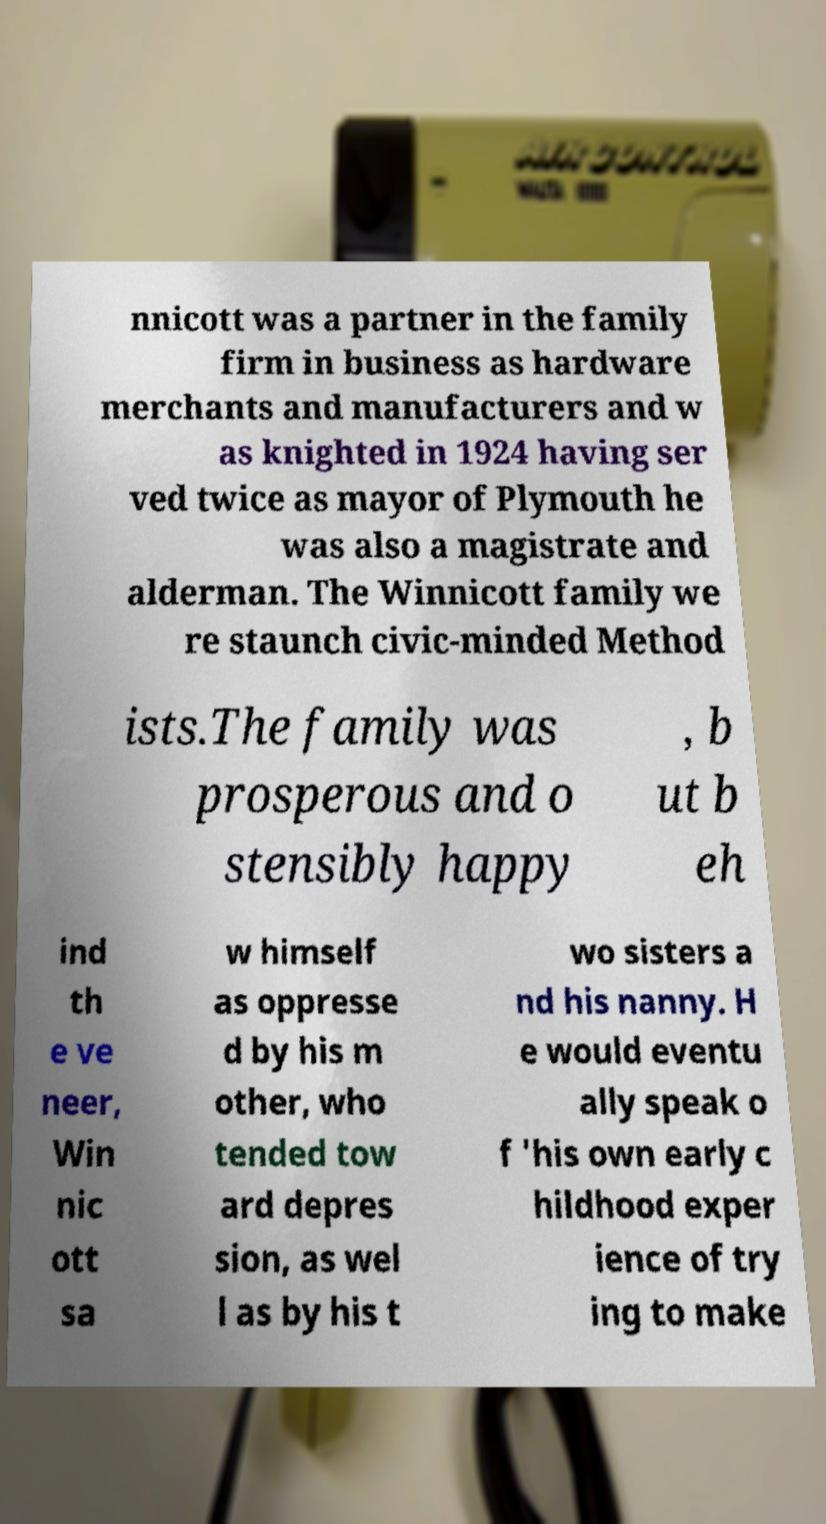Please read and relay the text visible in this image. What does it say? nnicott was a partner in the family firm in business as hardware merchants and manufacturers and w as knighted in 1924 having ser ved twice as mayor of Plymouth he was also a magistrate and alderman. The Winnicott family we re staunch civic-minded Method ists.The family was prosperous and o stensibly happy , b ut b eh ind th e ve neer, Win nic ott sa w himself as oppresse d by his m other, who tended tow ard depres sion, as wel l as by his t wo sisters a nd his nanny. H e would eventu ally speak o f 'his own early c hildhood exper ience of try ing to make 